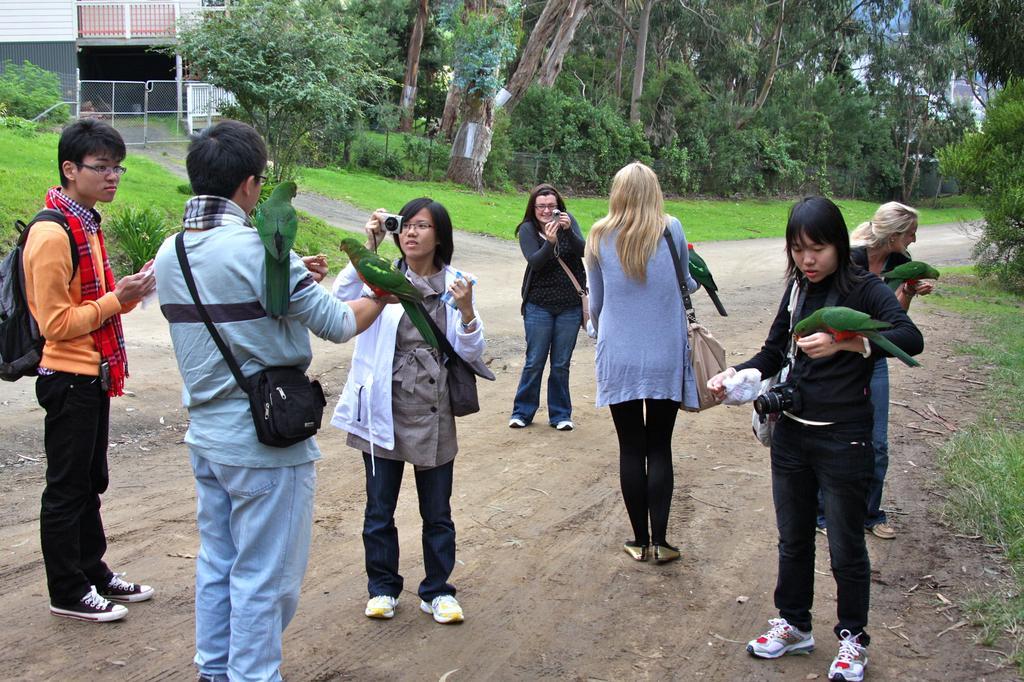Could you give a brief overview of what you see in this image? In this image we can see a few people, two of them are taking pictures, there are some parrots on the people, there are trees plants, house, also we can see the sky. 